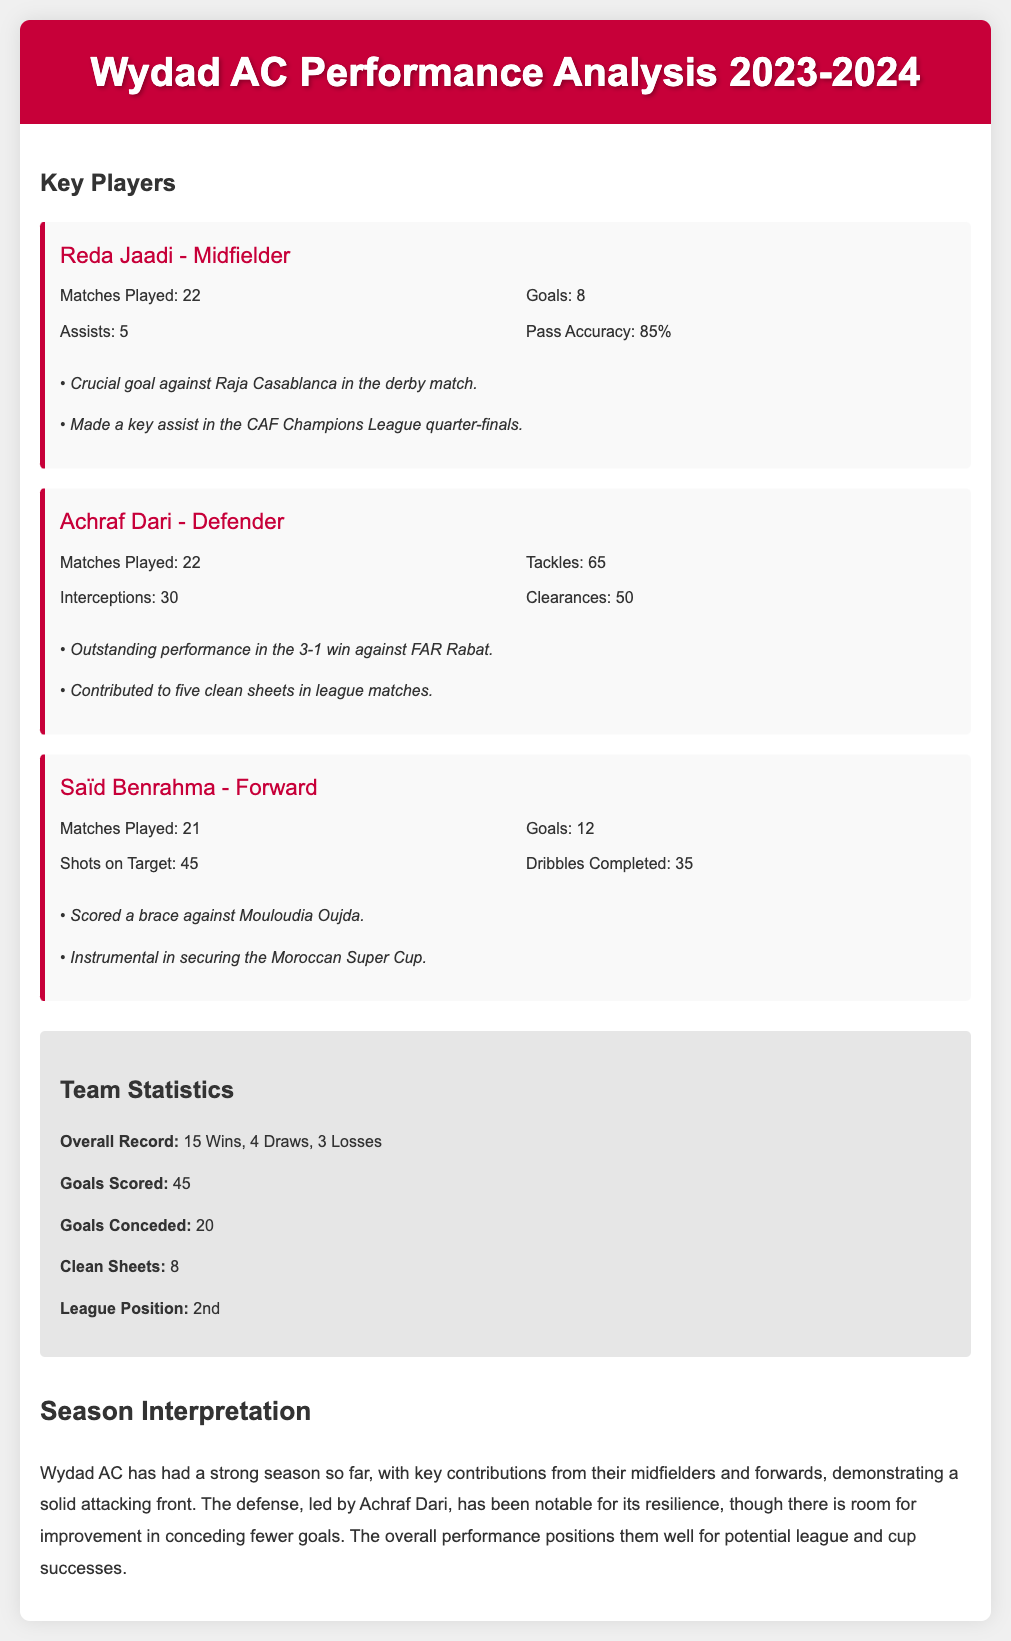What is the number of matches played by Reda Jaadi? The number of matches played by Reda Jaadi is explicitly mentioned in his player card.
Answer: 22 How many goals did Saïd Benrahma score this season? The goals scored by Saïd Benrahma are listed in his player performance statistics.
Answer: 12 What is Achraf Dari's number of clearances? Achraf Dari's clearances are stated in his performance statistics section.
Answer: 50 What is Wydad AC's overall record for the season? The overall record of Wydad AC, including wins, draws, and losses, is summarized in the team statistics.
Answer: 15 Wins, 4 Draws, 3 Losses How many assists did Reda Jaadi provide? The number of assists by Reda Jaadi is shown in his individual player performance data.
Answer: 5 Which player scored a brace against Mouloudia Oujda? The document explicitly mentions the player who scored a brace in the highlights section.
Answer: Saïd Benrahma What is the team's league position? The league position of Wydad AC is detailed in the team statistics section.
Answer: 2nd How many clean sheets has the team recorded this season? The total clean sheets for Wydad AC are provided in the team statistics.
Answer: 8 What was a highlight of Achraf Dari’s performance? Achraf Dari's standout performance is listed in the highlights of his player card.
Answer: Outstanding performance in the 3-1 win against FAR Rabat 